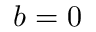<formula> <loc_0><loc_0><loc_500><loc_500>b = 0</formula> 